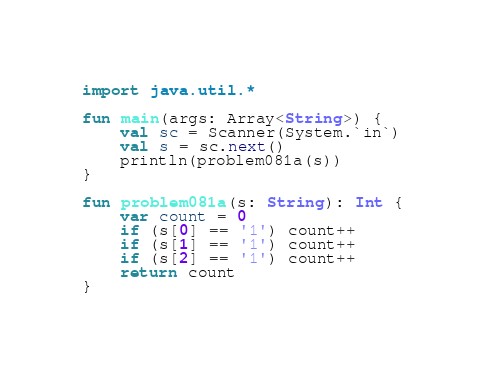Convert code to text. <code><loc_0><loc_0><loc_500><loc_500><_Kotlin_>import java.util.*

fun main(args: Array<String>) {
    val sc = Scanner(System.`in`)
    val s = sc.next()
    println(problem081a(s))
}

fun problem081a(s: String): Int {
    var count = 0
    if (s[0] == '1') count++
    if (s[1] == '1') count++
    if (s[2] == '1') count++
    return count
}</code> 